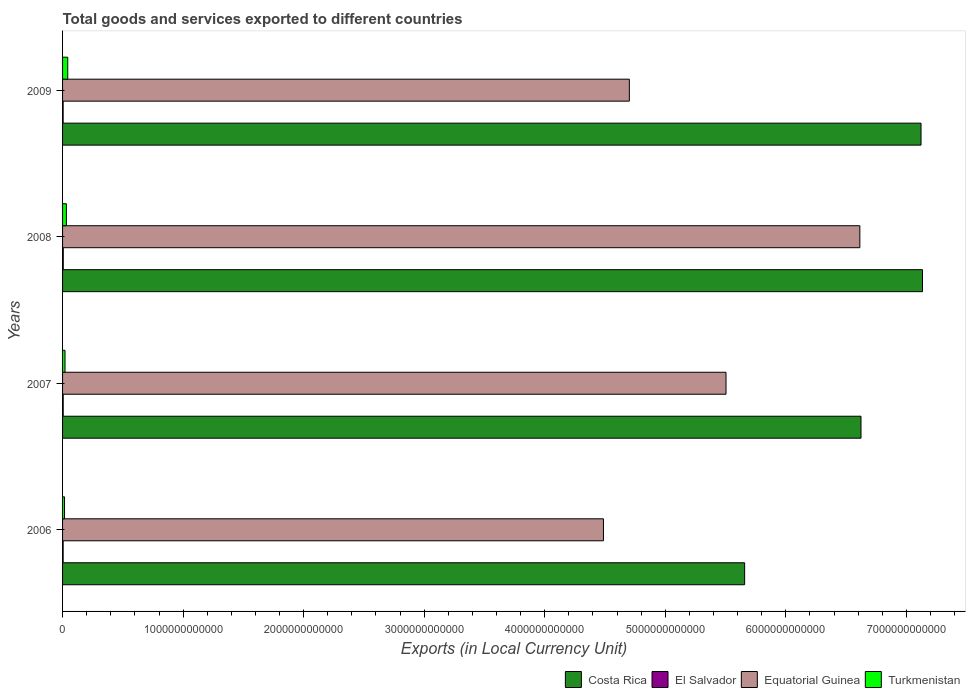How many different coloured bars are there?
Your response must be concise. 4. Are the number of bars on each tick of the Y-axis equal?
Offer a terse response. Yes. How many bars are there on the 1st tick from the top?
Your response must be concise. 4. How many bars are there on the 2nd tick from the bottom?
Your answer should be very brief. 4. What is the label of the 1st group of bars from the top?
Your answer should be very brief. 2009. What is the Amount of goods and services exports in Turkmenistan in 2006?
Offer a very short reply. 1.63e+1. Across all years, what is the maximum Amount of goods and services exports in Equatorial Guinea?
Your answer should be very brief. 6.61e+12. Across all years, what is the minimum Amount of goods and services exports in Costa Rica?
Ensure brevity in your answer.  5.66e+12. In which year was the Amount of goods and services exports in Turkmenistan maximum?
Your answer should be compact. 2009. What is the total Amount of goods and services exports in Equatorial Guinea in the graph?
Give a very brief answer. 2.13e+13. What is the difference between the Amount of goods and services exports in Costa Rica in 2007 and that in 2009?
Offer a very short reply. -4.98e+11. What is the difference between the Amount of goods and services exports in El Salvador in 2008 and the Amount of goods and services exports in Costa Rica in 2007?
Your answer should be very brief. -6.62e+12. What is the average Amount of goods and services exports in El Salvador per year?
Give a very brief answer. 5.13e+09. In the year 2009, what is the difference between the Amount of goods and services exports in Equatorial Guinea and Amount of goods and services exports in Costa Rica?
Your answer should be compact. -2.42e+12. In how many years, is the Amount of goods and services exports in Equatorial Guinea greater than 1400000000000 LCU?
Provide a short and direct response. 4. What is the ratio of the Amount of goods and services exports in Equatorial Guinea in 2008 to that in 2009?
Provide a succinct answer. 1.41. What is the difference between the highest and the second highest Amount of goods and services exports in El Salvador?
Make the answer very short. 5.57e+08. What is the difference between the highest and the lowest Amount of goods and services exports in Costa Rica?
Your response must be concise. 1.48e+12. Is the sum of the Amount of goods and services exports in El Salvador in 2008 and 2009 greater than the maximum Amount of goods and services exports in Turkmenistan across all years?
Ensure brevity in your answer.  No. Is it the case that in every year, the sum of the Amount of goods and services exports in El Salvador and Amount of goods and services exports in Equatorial Guinea is greater than the sum of Amount of goods and services exports in Costa Rica and Amount of goods and services exports in Turkmenistan?
Provide a short and direct response. No. What does the 1st bar from the bottom in 2007 represents?
Offer a terse response. Costa Rica. Is it the case that in every year, the sum of the Amount of goods and services exports in El Salvador and Amount of goods and services exports in Turkmenistan is greater than the Amount of goods and services exports in Costa Rica?
Your response must be concise. No. How many bars are there?
Make the answer very short. 16. Are all the bars in the graph horizontal?
Keep it short and to the point. Yes. How many years are there in the graph?
Ensure brevity in your answer.  4. What is the difference between two consecutive major ticks on the X-axis?
Your answer should be very brief. 1.00e+12. Are the values on the major ticks of X-axis written in scientific E-notation?
Your answer should be compact. No. Does the graph contain any zero values?
Provide a succinct answer. No. Does the graph contain grids?
Ensure brevity in your answer.  No. Where does the legend appear in the graph?
Keep it short and to the point. Bottom right. How many legend labels are there?
Ensure brevity in your answer.  4. What is the title of the graph?
Give a very brief answer. Total goods and services exported to different countries. What is the label or title of the X-axis?
Offer a very short reply. Exports (in Local Currency Unit). What is the label or title of the Y-axis?
Keep it short and to the point. Years. What is the Exports (in Local Currency Unit) of Costa Rica in 2006?
Make the answer very short. 5.66e+12. What is the Exports (in Local Currency Unit) of El Salvador in 2006?
Ensure brevity in your answer.  4.76e+09. What is the Exports (in Local Currency Unit) of Equatorial Guinea in 2006?
Ensure brevity in your answer.  4.49e+12. What is the Exports (in Local Currency Unit) in Turkmenistan in 2006?
Give a very brief answer. 1.63e+1. What is the Exports (in Local Currency Unit) of Costa Rica in 2007?
Your response must be concise. 6.62e+12. What is the Exports (in Local Currency Unit) of El Salvador in 2007?
Offer a terse response. 5.20e+09. What is the Exports (in Local Currency Unit) of Equatorial Guinea in 2007?
Provide a short and direct response. 5.50e+12. What is the Exports (in Local Currency Unit) of Turkmenistan in 2007?
Make the answer very short. 2.04e+1. What is the Exports (in Local Currency Unit) in Costa Rica in 2008?
Give a very brief answer. 7.13e+12. What is the Exports (in Local Currency Unit) of El Salvador in 2008?
Ensure brevity in your answer.  5.76e+09. What is the Exports (in Local Currency Unit) in Equatorial Guinea in 2008?
Offer a very short reply. 6.61e+12. What is the Exports (in Local Currency Unit) of Turkmenistan in 2008?
Give a very brief answer. 3.17e+1. What is the Exports (in Local Currency Unit) of Costa Rica in 2009?
Provide a succinct answer. 7.12e+12. What is the Exports (in Local Currency Unit) in El Salvador in 2009?
Give a very brief answer. 4.79e+09. What is the Exports (in Local Currency Unit) in Equatorial Guinea in 2009?
Offer a very short reply. 4.70e+12. What is the Exports (in Local Currency Unit) of Turkmenistan in 2009?
Give a very brief answer. 4.30e+1. Across all years, what is the maximum Exports (in Local Currency Unit) of Costa Rica?
Your response must be concise. 7.13e+12. Across all years, what is the maximum Exports (in Local Currency Unit) of El Salvador?
Offer a terse response. 5.76e+09. Across all years, what is the maximum Exports (in Local Currency Unit) of Equatorial Guinea?
Your response must be concise. 6.61e+12. Across all years, what is the maximum Exports (in Local Currency Unit) of Turkmenistan?
Make the answer very short. 4.30e+1. Across all years, what is the minimum Exports (in Local Currency Unit) of Costa Rica?
Offer a very short reply. 5.66e+12. Across all years, what is the minimum Exports (in Local Currency Unit) of El Salvador?
Provide a succinct answer. 4.76e+09. Across all years, what is the minimum Exports (in Local Currency Unit) in Equatorial Guinea?
Your answer should be very brief. 4.49e+12. Across all years, what is the minimum Exports (in Local Currency Unit) in Turkmenistan?
Your answer should be compact. 1.63e+1. What is the total Exports (in Local Currency Unit) of Costa Rica in the graph?
Provide a short and direct response. 2.65e+13. What is the total Exports (in Local Currency Unit) of El Salvador in the graph?
Offer a terse response. 2.05e+1. What is the total Exports (in Local Currency Unit) of Equatorial Guinea in the graph?
Offer a terse response. 2.13e+13. What is the total Exports (in Local Currency Unit) in Turkmenistan in the graph?
Your response must be concise. 1.11e+11. What is the difference between the Exports (in Local Currency Unit) of Costa Rica in 2006 and that in 2007?
Your answer should be compact. -9.65e+11. What is the difference between the Exports (in Local Currency Unit) in El Salvador in 2006 and that in 2007?
Offer a very short reply. -4.40e+08. What is the difference between the Exports (in Local Currency Unit) of Equatorial Guinea in 2006 and that in 2007?
Your answer should be very brief. -1.02e+12. What is the difference between the Exports (in Local Currency Unit) in Turkmenistan in 2006 and that in 2007?
Ensure brevity in your answer.  -4.09e+09. What is the difference between the Exports (in Local Currency Unit) of Costa Rica in 2006 and that in 2008?
Offer a terse response. -1.48e+12. What is the difference between the Exports (in Local Currency Unit) of El Salvador in 2006 and that in 2008?
Provide a succinct answer. -9.97e+08. What is the difference between the Exports (in Local Currency Unit) of Equatorial Guinea in 2006 and that in 2008?
Give a very brief answer. -2.13e+12. What is the difference between the Exports (in Local Currency Unit) of Turkmenistan in 2006 and that in 2008?
Offer a terse response. -1.54e+1. What is the difference between the Exports (in Local Currency Unit) of Costa Rica in 2006 and that in 2009?
Provide a succinct answer. -1.46e+12. What is the difference between the Exports (in Local Currency Unit) in El Salvador in 2006 and that in 2009?
Provide a short and direct response. -2.85e+07. What is the difference between the Exports (in Local Currency Unit) in Equatorial Guinea in 2006 and that in 2009?
Keep it short and to the point. -2.15e+11. What is the difference between the Exports (in Local Currency Unit) in Turkmenistan in 2006 and that in 2009?
Provide a succinct answer. -2.67e+1. What is the difference between the Exports (in Local Currency Unit) in Costa Rica in 2007 and that in 2008?
Provide a short and direct response. -5.10e+11. What is the difference between the Exports (in Local Currency Unit) in El Salvador in 2007 and that in 2008?
Your response must be concise. -5.57e+08. What is the difference between the Exports (in Local Currency Unit) of Equatorial Guinea in 2007 and that in 2008?
Your answer should be very brief. -1.11e+12. What is the difference between the Exports (in Local Currency Unit) of Turkmenistan in 2007 and that in 2008?
Offer a very short reply. -1.13e+1. What is the difference between the Exports (in Local Currency Unit) in Costa Rica in 2007 and that in 2009?
Provide a succinct answer. -4.98e+11. What is the difference between the Exports (in Local Currency Unit) of El Salvador in 2007 and that in 2009?
Your answer should be compact. 4.11e+08. What is the difference between the Exports (in Local Currency Unit) of Equatorial Guinea in 2007 and that in 2009?
Keep it short and to the point. 8.02e+11. What is the difference between the Exports (in Local Currency Unit) in Turkmenistan in 2007 and that in 2009?
Keep it short and to the point. -2.26e+1. What is the difference between the Exports (in Local Currency Unit) in Costa Rica in 2008 and that in 2009?
Keep it short and to the point. 1.21e+1. What is the difference between the Exports (in Local Currency Unit) in El Salvador in 2008 and that in 2009?
Keep it short and to the point. 9.68e+08. What is the difference between the Exports (in Local Currency Unit) in Equatorial Guinea in 2008 and that in 2009?
Provide a short and direct response. 1.91e+12. What is the difference between the Exports (in Local Currency Unit) of Turkmenistan in 2008 and that in 2009?
Provide a succinct answer. -1.13e+1. What is the difference between the Exports (in Local Currency Unit) in Costa Rica in 2006 and the Exports (in Local Currency Unit) in El Salvador in 2007?
Keep it short and to the point. 5.65e+12. What is the difference between the Exports (in Local Currency Unit) of Costa Rica in 2006 and the Exports (in Local Currency Unit) of Equatorial Guinea in 2007?
Make the answer very short. 1.55e+11. What is the difference between the Exports (in Local Currency Unit) in Costa Rica in 2006 and the Exports (in Local Currency Unit) in Turkmenistan in 2007?
Provide a succinct answer. 5.64e+12. What is the difference between the Exports (in Local Currency Unit) of El Salvador in 2006 and the Exports (in Local Currency Unit) of Equatorial Guinea in 2007?
Provide a succinct answer. -5.50e+12. What is the difference between the Exports (in Local Currency Unit) in El Salvador in 2006 and the Exports (in Local Currency Unit) in Turkmenistan in 2007?
Offer a very short reply. -1.56e+1. What is the difference between the Exports (in Local Currency Unit) of Equatorial Guinea in 2006 and the Exports (in Local Currency Unit) of Turkmenistan in 2007?
Provide a succinct answer. 4.47e+12. What is the difference between the Exports (in Local Currency Unit) of Costa Rica in 2006 and the Exports (in Local Currency Unit) of El Salvador in 2008?
Provide a short and direct response. 5.65e+12. What is the difference between the Exports (in Local Currency Unit) in Costa Rica in 2006 and the Exports (in Local Currency Unit) in Equatorial Guinea in 2008?
Offer a very short reply. -9.56e+11. What is the difference between the Exports (in Local Currency Unit) of Costa Rica in 2006 and the Exports (in Local Currency Unit) of Turkmenistan in 2008?
Give a very brief answer. 5.63e+12. What is the difference between the Exports (in Local Currency Unit) in El Salvador in 2006 and the Exports (in Local Currency Unit) in Equatorial Guinea in 2008?
Your response must be concise. -6.61e+12. What is the difference between the Exports (in Local Currency Unit) in El Salvador in 2006 and the Exports (in Local Currency Unit) in Turkmenistan in 2008?
Offer a very short reply. -2.69e+1. What is the difference between the Exports (in Local Currency Unit) in Equatorial Guinea in 2006 and the Exports (in Local Currency Unit) in Turkmenistan in 2008?
Give a very brief answer. 4.46e+12. What is the difference between the Exports (in Local Currency Unit) in Costa Rica in 2006 and the Exports (in Local Currency Unit) in El Salvador in 2009?
Ensure brevity in your answer.  5.65e+12. What is the difference between the Exports (in Local Currency Unit) in Costa Rica in 2006 and the Exports (in Local Currency Unit) in Equatorial Guinea in 2009?
Make the answer very short. 9.57e+11. What is the difference between the Exports (in Local Currency Unit) of Costa Rica in 2006 and the Exports (in Local Currency Unit) of Turkmenistan in 2009?
Give a very brief answer. 5.62e+12. What is the difference between the Exports (in Local Currency Unit) of El Salvador in 2006 and the Exports (in Local Currency Unit) of Equatorial Guinea in 2009?
Provide a short and direct response. -4.70e+12. What is the difference between the Exports (in Local Currency Unit) in El Salvador in 2006 and the Exports (in Local Currency Unit) in Turkmenistan in 2009?
Provide a short and direct response. -3.82e+1. What is the difference between the Exports (in Local Currency Unit) of Equatorial Guinea in 2006 and the Exports (in Local Currency Unit) of Turkmenistan in 2009?
Offer a terse response. 4.44e+12. What is the difference between the Exports (in Local Currency Unit) of Costa Rica in 2007 and the Exports (in Local Currency Unit) of El Salvador in 2008?
Offer a terse response. 6.62e+12. What is the difference between the Exports (in Local Currency Unit) in Costa Rica in 2007 and the Exports (in Local Currency Unit) in Equatorial Guinea in 2008?
Offer a very short reply. 9.63e+09. What is the difference between the Exports (in Local Currency Unit) of Costa Rica in 2007 and the Exports (in Local Currency Unit) of Turkmenistan in 2008?
Offer a very short reply. 6.59e+12. What is the difference between the Exports (in Local Currency Unit) in El Salvador in 2007 and the Exports (in Local Currency Unit) in Equatorial Guinea in 2008?
Offer a very short reply. -6.61e+12. What is the difference between the Exports (in Local Currency Unit) in El Salvador in 2007 and the Exports (in Local Currency Unit) in Turkmenistan in 2008?
Keep it short and to the point. -2.65e+1. What is the difference between the Exports (in Local Currency Unit) of Equatorial Guinea in 2007 and the Exports (in Local Currency Unit) of Turkmenistan in 2008?
Your answer should be very brief. 5.47e+12. What is the difference between the Exports (in Local Currency Unit) in Costa Rica in 2007 and the Exports (in Local Currency Unit) in El Salvador in 2009?
Keep it short and to the point. 6.62e+12. What is the difference between the Exports (in Local Currency Unit) in Costa Rica in 2007 and the Exports (in Local Currency Unit) in Equatorial Guinea in 2009?
Ensure brevity in your answer.  1.92e+12. What is the difference between the Exports (in Local Currency Unit) in Costa Rica in 2007 and the Exports (in Local Currency Unit) in Turkmenistan in 2009?
Offer a very short reply. 6.58e+12. What is the difference between the Exports (in Local Currency Unit) in El Salvador in 2007 and the Exports (in Local Currency Unit) in Equatorial Guinea in 2009?
Your response must be concise. -4.70e+12. What is the difference between the Exports (in Local Currency Unit) of El Salvador in 2007 and the Exports (in Local Currency Unit) of Turkmenistan in 2009?
Offer a very short reply. -3.78e+1. What is the difference between the Exports (in Local Currency Unit) in Equatorial Guinea in 2007 and the Exports (in Local Currency Unit) in Turkmenistan in 2009?
Offer a very short reply. 5.46e+12. What is the difference between the Exports (in Local Currency Unit) of Costa Rica in 2008 and the Exports (in Local Currency Unit) of El Salvador in 2009?
Provide a succinct answer. 7.13e+12. What is the difference between the Exports (in Local Currency Unit) of Costa Rica in 2008 and the Exports (in Local Currency Unit) of Equatorial Guinea in 2009?
Make the answer very short. 2.43e+12. What is the difference between the Exports (in Local Currency Unit) of Costa Rica in 2008 and the Exports (in Local Currency Unit) of Turkmenistan in 2009?
Keep it short and to the point. 7.09e+12. What is the difference between the Exports (in Local Currency Unit) of El Salvador in 2008 and the Exports (in Local Currency Unit) of Equatorial Guinea in 2009?
Ensure brevity in your answer.  -4.70e+12. What is the difference between the Exports (in Local Currency Unit) in El Salvador in 2008 and the Exports (in Local Currency Unit) in Turkmenistan in 2009?
Ensure brevity in your answer.  -3.72e+1. What is the difference between the Exports (in Local Currency Unit) in Equatorial Guinea in 2008 and the Exports (in Local Currency Unit) in Turkmenistan in 2009?
Make the answer very short. 6.57e+12. What is the average Exports (in Local Currency Unit) in Costa Rica per year?
Offer a terse response. 6.63e+12. What is the average Exports (in Local Currency Unit) of El Salvador per year?
Offer a very short reply. 5.13e+09. What is the average Exports (in Local Currency Unit) of Equatorial Guinea per year?
Provide a short and direct response. 5.33e+12. What is the average Exports (in Local Currency Unit) in Turkmenistan per year?
Keep it short and to the point. 2.78e+1. In the year 2006, what is the difference between the Exports (in Local Currency Unit) in Costa Rica and Exports (in Local Currency Unit) in El Salvador?
Provide a short and direct response. 5.65e+12. In the year 2006, what is the difference between the Exports (in Local Currency Unit) of Costa Rica and Exports (in Local Currency Unit) of Equatorial Guinea?
Keep it short and to the point. 1.17e+12. In the year 2006, what is the difference between the Exports (in Local Currency Unit) of Costa Rica and Exports (in Local Currency Unit) of Turkmenistan?
Make the answer very short. 5.64e+12. In the year 2006, what is the difference between the Exports (in Local Currency Unit) of El Salvador and Exports (in Local Currency Unit) of Equatorial Guinea?
Your response must be concise. -4.48e+12. In the year 2006, what is the difference between the Exports (in Local Currency Unit) of El Salvador and Exports (in Local Currency Unit) of Turkmenistan?
Your answer should be compact. -1.15e+1. In the year 2006, what is the difference between the Exports (in Local Currency Unit) of Equatorial Guinea and Exports (in Local Currency Unit) of Turkmenistan?
Your response must be concise. 4.47e+12. In the year 2007, what is the difference between the Exports (in Local Currency Unit) of Costa Rica and Exports (in Local Currency Unit) of El Salvador?
Ensure brevity in your answer.  6.62e+12. In the year 2007, what is the difference between the Exports (in Local Currency Unit) of Costa Rica and Exports (in Local Currency Unit) of Equatorial Guinea?
Ensure brevity in your answer.  1.12e+12. In the year 2007, what is the difference between the Exports (in Local Currency Unit) in Costa Rica and Exports (in Local Currency Unit) in Turkmenistan?
Give a very brief answer. 6.60e+12. In the year 2007, what is the difference between the Exports (in Local Currency Unit) of El Salvador and Exports (in Local Currency Unit) of Equatorial Guinea?
Ensure brevity in your answer.  -5.50e+12. In the year 2007, what is the difference between the Exports (in Local Currency Unit) of El Salvador and Exports (in Local Currency Unit) of Turkmenistan?
Provide a short and direct response. -1.52e+1. In the year 2007, what is the difference between the Exports (in Local Currency Unit) of Equatorial Guinea and Exports (in Local Currency Unit) of Turkmenistan?
Make the answer very short. 5.48e+12. In the year 2008, what is the difference between the Exports (in Local Currency Unit) in Costa Rica and Exports (in Local Currency Unit) in El Salvador?
Your answer should be compact. 7.13e+12. In the year 2008, what is the difference between the Exports (in Local Currency Unit) in Costa Rica and Exports (in Local Currency Unit) in Equatorial Guinea?
Your answer should be compact. 5.20e+11. In the year 2008, what is the difference between the Exports (in Local Currency Unit) in Costa Rica and Exports (in Local Currency Unit) in Turkmenistan?
Provide a succinct answer. 7.10e+12. In the year 2008, what is the difference between the Exports (in Local Currency Unit) of El Salvador and Exports (in Local Currency Unit) of Equatorial Guinea?
Your answer should be compact. -6.61e+12. In the year 2008, what is the difference between the Exports (in Local Currency Unit) of El Salvador and Exports (in Local Currency Unit) of Turkmenistan?
Your answer should be very brief. -2.59e+1. In the year 2008, what is the difference between the Exports (in Local Currency Unit) in Equatorial Guinea and Exports (in Local Currency Unit) in Turkmenistan?
Your answer should be very brief. 6.58e+12. In the year 2009, what is the difference between the Exports (in Local Currency Unit) of Costa Rica and Exports (in Local Currency Unit) of El Salvador?
Your response must be concise. 7.12e+12. In the year 2009, what is the difference between the Exports (in Local Currency Unit) in Costa Rica and Exports (in Local Currency Unit) in Equatorial Guinea?
Your answer should be compact. 2.42e+12. In the year 2009, what is the difference between the Exports (in Local Currency Unit) of Costa Rica and Exports (in Local Currency Unit) of Turkmenistan?
Provide a succinct answer. 7.08e+12. In the year 2009, what is the difference between the Exports (in Local Currency Unit) of El Salvador and Exports (in Local Currency Unit) of Equatorial Guinea?
Ensure brevity in your answer.  -4.70e+12. In the year 2009, what is the difference between the Exports (in Local Currency Unit) in El Salvador and Exports (in Local Currency Unit) in Turkmenistan?
Your response must be concise. -3.82e+1. In the year 2009, what is the difference between the Exports (in Local Currency Unit) in Equatorial Guinea and Exports (in Local Currency Unit) in Turkmenistan?
Make the answer very short. 4.66e+12. What is the ratio of the Exports (in Local Currency Unit) in Costa Rica in 2006 to that in 2007?
Your answer should be very brief. 0.85. What is the ratio of the Exports (in Local Currency Unit) of El Salvador in 2006 to that in 2007?
Keep it short and to the point. 0.92. What is the ratio of the Exports (in Local Currency Unit) in Equatorial Guinea in 2006 to that in 2007?
Make the answer very short. 0.82. What is the ratio of the Exports (in Local Currency Unit) in Turkmenistan in 2006 to that in 2007?
Keep it short and to the point. 0.8. What is the ratio of the Exports (in Local Currency Unit) in Costa Rica in 2006 to that in 2008?
Give a very brief answer. 0.79. What is the ratio of the Exports (in Local Currency Unit) of El Salvador in 2006 to that in 2008?
Make the answer very short. 0.83. What is the ratio of the Exports (in Local Currency Unit) of Equatorial Guinea in 2006 to that in 2008?
Ensure brevity in your answer.  0.68. What is the ratio of the Exports (in Local Currency Unit) of Turkmenistan in 2006 to that in 2008?
Keep it short and to the point. 0.51. What is the ratio of the Exports (in Local Currency Unit) in Costa Rica in 2006 to that in 2009?
Keep it short and to the point. 0.79. What is the ratio of the Exports (in Local Currency Unit) of El Salvador in 2006 to that in 2009?
Keep it short and to the point. 0.99. What is the ratio of the Exports (in Local Currency Unit) of Equatorial Guinea in 2006 to that in 2009?
Ensure brevity in your answer.  0.95. What is the ratio of the Exports (in Local Currency Unit) of Turkmenistan in 2006 to that in 2009?
Offer a terse response. 0.38. What is the ratio of the Exports (in Local Currency Unit) in Costa Rica in 2007 to that in 2008?
Provide a short and direct response. 0.93. What is the ratio of the Exports (in Local Currency Unit) in El Salvador in 2007 to that in 2008?
Give a very brief answer. 0.9. What is the ratio of the Exports (in Local Currency Unit) in Equatorial Guinea in 2007 to that in 2008?
Provide a short and direct response. 0.83. What is the ratio of the Exports (in Local Currency Unit) of Turkmenistan in 2007 to that in 2008?
Provide a short and direct response. 0.64. What is the ratio of the Exports (in Local Currency Unit) in Costa Rica in 2007 to that in 2009?
Offer a very short reply. 0.93. What is the ratio of the Exports (in Local Currency Unit) in El Salvador in 2007 to that in 2009?
Provide a short and direct response. 1.09. What is the ratio of the Exports (in Local Currency Unit) in Equatorial Guinea in 2007 to that in 2009?
Your answer should be compact. 1.17. What is the ratio of the Exports (in Local Currency Unit) in Turkmenistan in 2007 to that in 2009?
Make the answer very short. 0.47. What is the ratio of the Exports (in Local Currency Unit) of El Salvador in 2008 to that in 2009?
Keep it short and to the point. 1.2. What is the ratio of the Exports (in Local Currency Unit) of Equatorial Guinea in 2008 to that in 2009?
Your answer should be compact. 1.41. What is the ratio of the Exports (in Local Currency Unit) of Turkmenistan in 2008 to that in 2009?
Give a very brief answer. 0.74. What is the difference between the highest and the second highest Exports (in Local Currency Unit) of Costa Rica?
Provide a succinct answer. 1.21e+1. What is the difference between the highest and the second highest Exports (in Local Currency Unit) of El Salvador?
Your response must be concise. 5.57e+08. What is the difference between the highest and the second highest Exports (in Local Currency Unit) in Equatorial Guinea?
Your response must be concise. 1.11e+12. What is the difference between the highest and the second highest Exports (in Local Currency Unit) of Turkmenistan?
Keep it short and to the point. 1.13e+1. What is the difference between the highest and the lowest Exports (in Local Currency Unit) of Costa Rica?
Your answer should be compact. 1.48e+12. What is the difference between the highest and the lowest Exports (in Local Currency Unit) of El Salvador?
Give a very brief answer. 9.97e+08. What is the difference between the highest and the lowest Exports (in Local Currency Unit) of Equatorial Guinea?
Offer a terse response. 2.13e+12. What is the difference between the highest and the lowest Exports (in Local Currency Unit) in Turkmenistan?
Make the answer very short. 2.67e+1. 